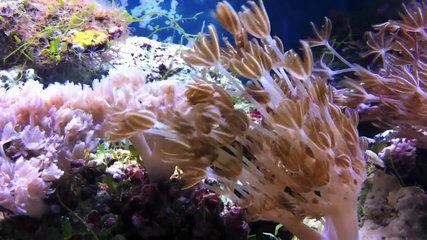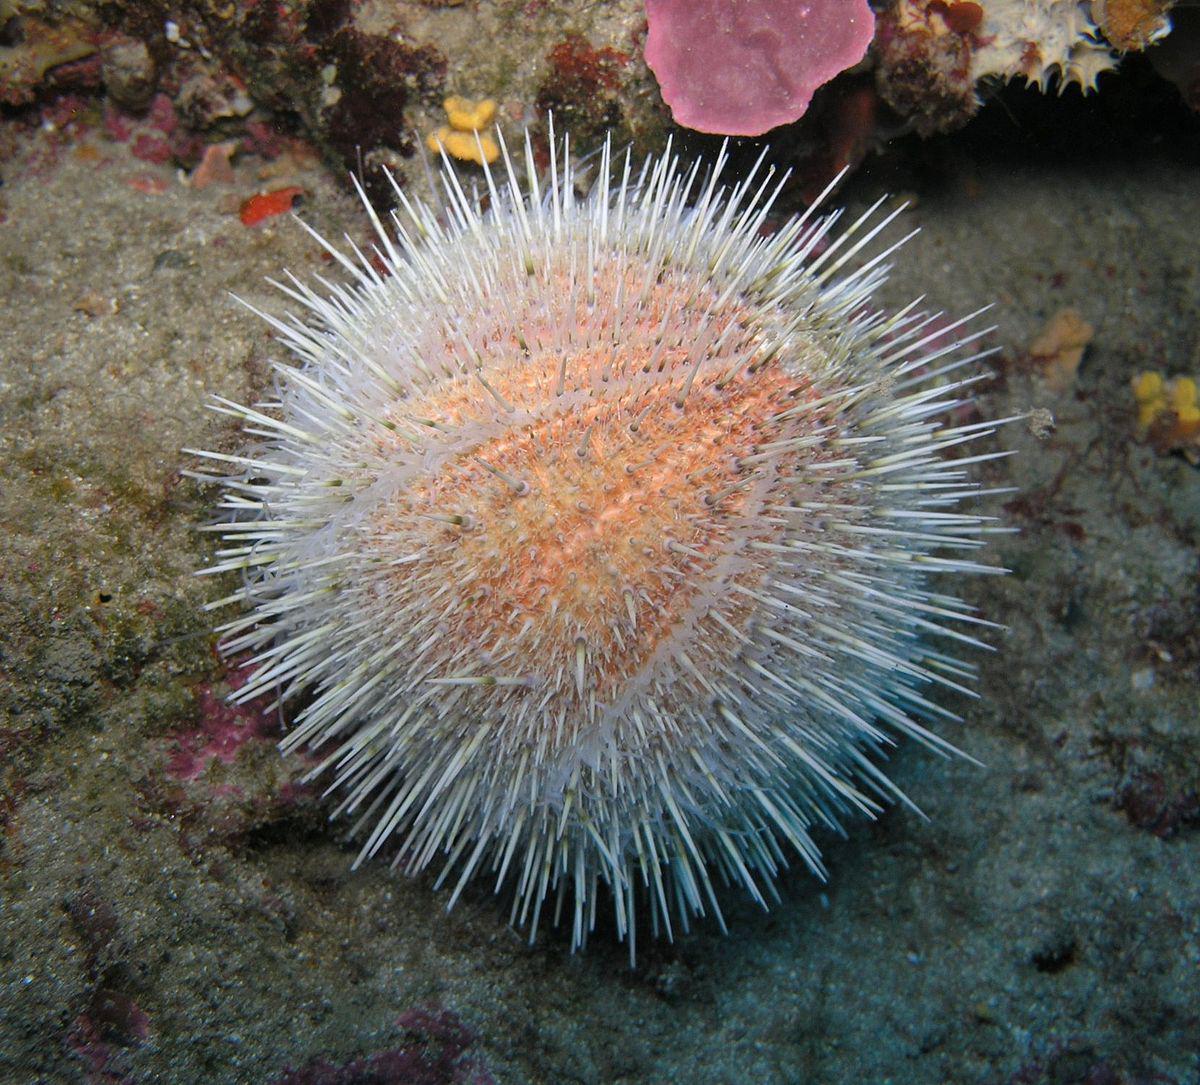The first image is the image on the left, the second image is the image on the right. Considering the images on both sides, is "The left image contains one anemone, which has orangish color, tapered tendrils, and a darker center with a """"mouth"""" opening." valid? Answer yes or no. No. 